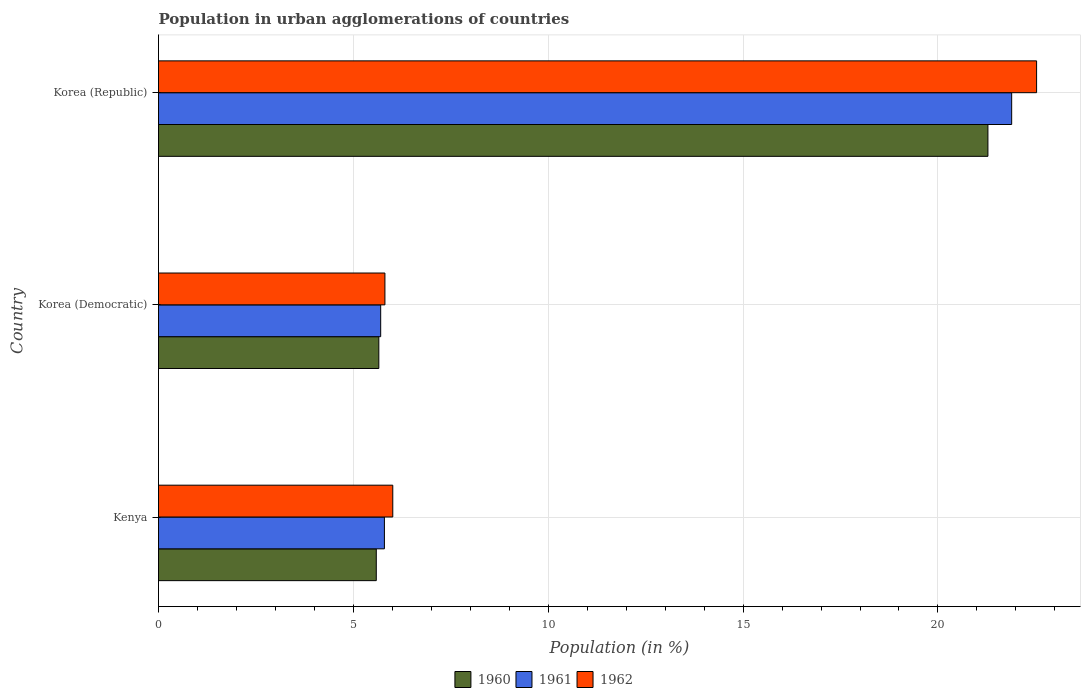How many bars are there on the 3rd tick from the top?
Offer a terse response. 3. How many bars are there on the 3rd tick from the bottom?
Provide a succinct answer. 3. What is the label of the 2nd group of bars from the top?
Ensure brevity in your answer.  Korea (Democratic). What is the percentage of population in urban agglomerations in 1961 in Korea (Democratic)?
Your answer should be very brief. 5.7. Across all countries, what is the maximum percentage of population in urban agglomerations in 1961?
Keep it short and to the point. 21.89. Across all countries, what is the minimum percentage of population in urban agglomerations in 1962?
Make the answer very short. 5.81. In which country was the percentage of population in urban agglomerations in 1961 maximum?
Provide a succinct answer. Korea (Republic). In which country was the percentage of population in urban agglomerations in 1961 minimum?
Give a very brief answer. Korea (Democratic). What is the total percentage of population in urban agglomerations in 1961 in the graph?
Your answer should be compact. 33.39. What is the difference between the percentage of population in urban agglomerations in 1961 in Kenya and that in Korea (Republic)?
Provide a succinct answer. -16.1. What is the difference between the percentage of population in urban agglomerations in 1962 in Kenya and the percentage of population in urban agglomerations in 1961 in Korea (Republic)?
Provide a succinct answer. -15.88. What is the average percentage of population in urban agglomerations in 1960 per country?
Your answer should be very brief. 10.84. What is the difference between the percentage of population in urban agglomerations in 1962 and percentage of population in urban agglomerations in 1961 in Korea (Democratic)?
Provide a short and direct response. 0.11. In how many countries, is the percentage of population in urban agglomerations in 1960 greater than 22 %?
Your response must be concise. 0. What is the ratio of the percentage of population in urban agglomerations in 1962 in Korea (Democratic) to that in Korea (Republic)?
Ensure brevity in your answer.  0.26. Is the percentage of population in urban agglomerations in 1962 in Korea (Democratic) less than that in Korea (Republic)?
Ensure brevity in your answer.  Yes. What is the difference between the highest and the second highest percentage of population in urban agglomerations in 1962?
Offer a terse response. 16.52. What is the difference between the highest and the lowest percentage of population in urban agglomerations in 1961?
Your answer should be compact. 16.19. What does the 3rd bar from the top in Korea (Republic) represents?
Make the answer very short. 1960. Is it the case that in every country, the sum of the percentage of population in urban agglomerations in 1960 and percentage of population in urban agglomerations in 1961 is greater than the percentage of population in urban agglomerations in 1962?
Your response must be concise. Yes. Are all the bars in the graph horizontal?
Ensure brevity in your answer.  Yes. How many countries are there in the graph?
Offer a terse response. 3. Are the values on the major ticks of X-axis written in scientific E-notation?
Ensure brevity in your answer.  No. Does the graph contain any zero values?
Your answer should be compact. No. What is the title of the graph?
Offer a terse response. Population in urban agglomerations of countries. What is the label or title of the X-axis?
Offer a terse response. Population (in %). What is the Population (in %) of 1960 in Kenya?
Your response must be concise. 5.59. What is the Population (in %) of 1961 in Kenya?
Provide a short and direct response. 5.8. What is the Population (in %) of 1962 in Kenya?
Keep it short and to the point. 6.01. What is the Population (in %) in 1960 in Korea (Democratic)?
Provide a succinct answer. 5.65. What is the Population (in %) of 1961 in Korea (Democratic)?
Give a very brief answer. 5.7. What is the Population (in %) of 1962 in Korea (Democratic)?
Your answer should be compact. 5.81. What is the Population (in %) in 1960 in Korea (Republic)?
Offer a very short reply. 21.28. What is the Population (in %) of 1961 in Korea (Republic)?
Ensure brevity in your answer.  21.89. What is the Population (in %) of 1962 in Korea (Republic)?
Keep it short and to the point. 22.53. Across all countries, what is the maximum Population (in %) of 1960?
Offer a very short reply. 21.28. Across all countries, what is the maximum Population (in %) of 1961?
Keep it short and to the point. 21.89. Across all countries, what is the maximum Population (in %) in 1962?
Your answer should be compact. 22.53. Across all countries, what is the minimum Population (in %) of 1960?
Your answer should be compact. 5.59. Across all countries, what is the minimum Population (in %) in 1961?
Make the answer very short. 5.7. Across all countries, what is the minimum Population (in %) in 1962?
Make the answer very short. 5.81. What is the total Population (in %) in 1960 in the graph?
Give a very brief answer. 32.52. What is the total Population (in %) of 1961 in the graph?
Ensure brevity in your answer.  33.39. What is the total Population (in %) of 1962 in the graph?
Give a very brief answer. 34.35. What is the difference between the Population (in %) in 1960 in Kenya and that in Korea (Democratic)?
Your answer should be compact. -0.07. What is the difference between the Population (in %) of 1961 in Kenya and that in Korea (Democratic)?
Make the answer very short. 0.1. What is the difference between the Population (in %) of 1962 in Kenya and that in Korea (Democratic)?
Provide a succinct answer. 0.2. What is the difference between the Population (in %) of 1960 in Kenya and that in Korea (Republic)?
Your response must be concise. -15.69. What is the difference between the Population (in %) in 1961 in Kenya and that in Korea (Republic)?
Offer a terse response. -16.1. What is the difference between the Population (in %) in 1962 in Kenya and that in Korea (Republic)?
Give a very brief answer. -16.52. What is the difference between the Population (in %) of 1960 in Korea (Democratic) and that in Korea (Republic)?
Your answer should be compact. -15.63. What is the difference between the Population (in %) of 1961 in Korea (Democratic) and that in Korea (Republic)?
Provide a succinct answer. -16.19. What is the difference between the Population (in %) of 1962 in Korea (Democratic) and that in Korea (Republic)?
Make the answer very short. -16.72. What is the difference between the Population (in %) in 1960 in Kenya and the Population (in %) in 1961 in Korea (Democratic)?
Make the answer very short. -0.11. What is the difference between the Population (in %) in 1960 in Kenya and the Population (in %) in 1962 in Korea (Democratic)?
Give a very brief answer. -0.22. What is the difference between the Population (in %) in 1961 in Kenya and the Population (in %) in 1962 in Korea (Democratic)?
Keep it short and to the point. -0.01. What is the difference between the Population (in %) in 1960 in Kenya and the Population (in %) in 1961 in Korea (Republic)?
Your answer should be compact. -16.3. What is the difference between the Population (in %) in 1960 in Kenya and the Population (in %) in 1962 in Korea (Republic)?
Provide a short and direct response. -16.94. What is the difference between the Population (in %) in 1961 in Kenya and the Population (in %) in 1962 in Korea (Republic)?
Give a very brief answer. -16.73. What is the difference between the Population (in %) in 1960 in Korea (Democratic) and the Population (in %) in 1961 in Korea (Republic)?
Your answer should be very brief. -16.24. What is the difference between the Population (in %) of 1960 in Korea (Democratic) and the Population (in %) of 1962 in Korea (Republic)?
Offer a terse response. -16.88. What is the difference between the Population (in %) of 1961 in Korea (Democratic) and the Population (in %) of 1962 in Korea (Republic)?
Ensure brevity in your answer.  -16.83. What is the average Population (in %) in 1960 per country?
Your answer should be very brief. 10.84. What is the average Population (in %) of 1961 per country?
Your answer should be very brief. 11.13. What is the average Population (in %) in 1962 per country?
Give a very brief answer. 11.45. What is the difference between the Population (in %) of 1960 and Population (in %) of 1961 in Kenya?
Make the answer very short. -0.21. What is the difference between the Population (in %) in 1960 and Population (in %) in 1962 in Kenya?
Your response must be concise. -0.42. What is the difference between the Population (in %) of 1961 and Population (in %) of 1962 in Kenya?
Your answer should be very brief. -0.21. What is the difference between the Population (in %) in 1960 and Population (in %) in 1961 in Korea (Democratic)?
Your response must be concise. -0.05. What is the difference between the Population (in %) of 1960 and Population (in %) of 1962 in Korea (Democratic)?
Provide a short and direct response. -0.16. What is the difference between the Population (in %) in 1961 and Population (in %) in 1962 in Korea (Democratic)?
Offer a terse response. -0.11. What is the difference between the Population (in %) of 1960 and Population (in %) of 1961 in Korea (Republic)?
Your response must be concise. -0.61. What is the difference between the Population (in %) in 1960 and Population (in %) in 1962 in Korea (Republic)?
Your answer should be compact. -1.25. What is the difference between the Population (in %) of 1961 and Population (in %) of 1962 in Korea (Republic)?
Offer a very short reply. -0.64. What is the ratio of the Population (in %) in 1960 in Kenya to that in Korea (Democratic)?
Offer a terse response. 0.99. What is the ratio of the Population (in %) of 1961 in Kenya to that in Korea (Democratic)?
Provide a succinct answer. 1.02. What is the ratio of the Population (in %) in 1962 in Kenya to that in Korea (Democratic)?
Your response must be concise. 1.03. What is the ratio of the Population (in %) in 1960 in Kenya to that in Korea (Republic)?
Offer a terse response. 0.26. What is the ratio of the Population (in %) of 1961 in Kenya to that in Korea (Republic)?
Make the answer very short. 0.26. What is the ratio of the Population (in %) in 1962 in Kenya to that in Korea (Republic)?
Provide a succinct answer. 0.27. What is the ratio of the Population (in %) of 1960 in Korea (Democratic) to that in Korea (Republic)?
Your response must be concise. 0.27. What is the ratio of the Population (in %) of 1961 in Korea (Democratic) to that in Korea (Republic)?
Make the answer very short. 0.26. What is the ratio of the Population (in %) in 1962 in Korea (Democratic) to that in Korea (Republic)?
Offer a very short reply. 0.26. What is the difference between the highest and the second highest Population (in %) in 1960?
Provide a succinct answer. 15.63. What is the difference between the highest and the second highest Population (in %) of 1961?
Provide a succinct answer. 16.1. What is the difference between the highest and the second highest Population (in %) of 1962?
Offer a very short reply. 16.52. What is the difference between the highest and the lowest Population (in %) in 1960?
Provide a succinct answer. 15.69. What is the difference between the highest and the lowest Population (in %) of 1961?
Offer a very short reply. 16.19. What is the difference between the highest and the lowest Population (in %) of 1962?
Offer a terse response. 16.72. 